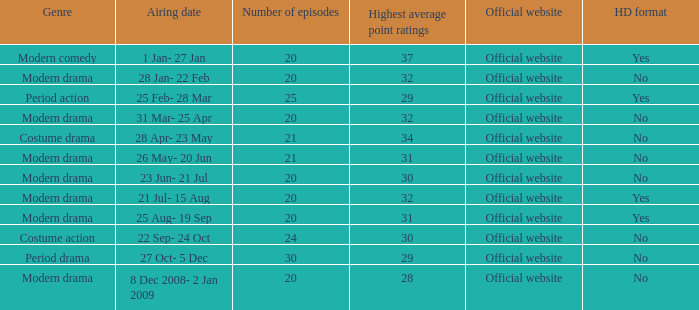What are the number of episodes when the genre is modern drama and the highest average ratings points are 28? 20.0. 